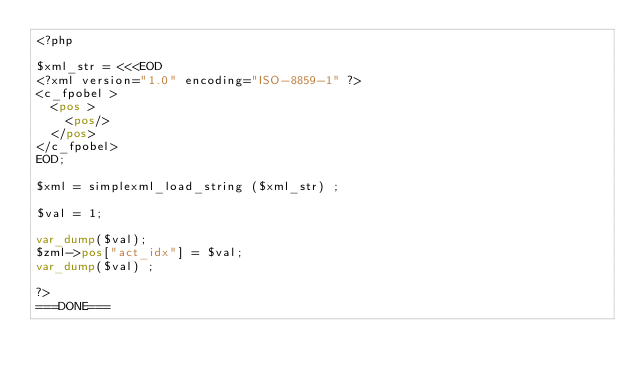<code> <loc_0><loc_0><loc_500><loc_500><_PHP_><?php

$xml_str = <<<EOD
<?xml version="1.0" encoding="ISO-8859-1" ?>
<c_fpobel >
  <pos >
    <pos/>
  </pos>
</c_fpobel>
EOD;

$xml = simplexml_load_string ($xml_str) ;

$val = 1;

var_dump($val);
$zml->pos["act_idx"] = $val;
var_dump($val) ;

?>
===DONE===
</code> 